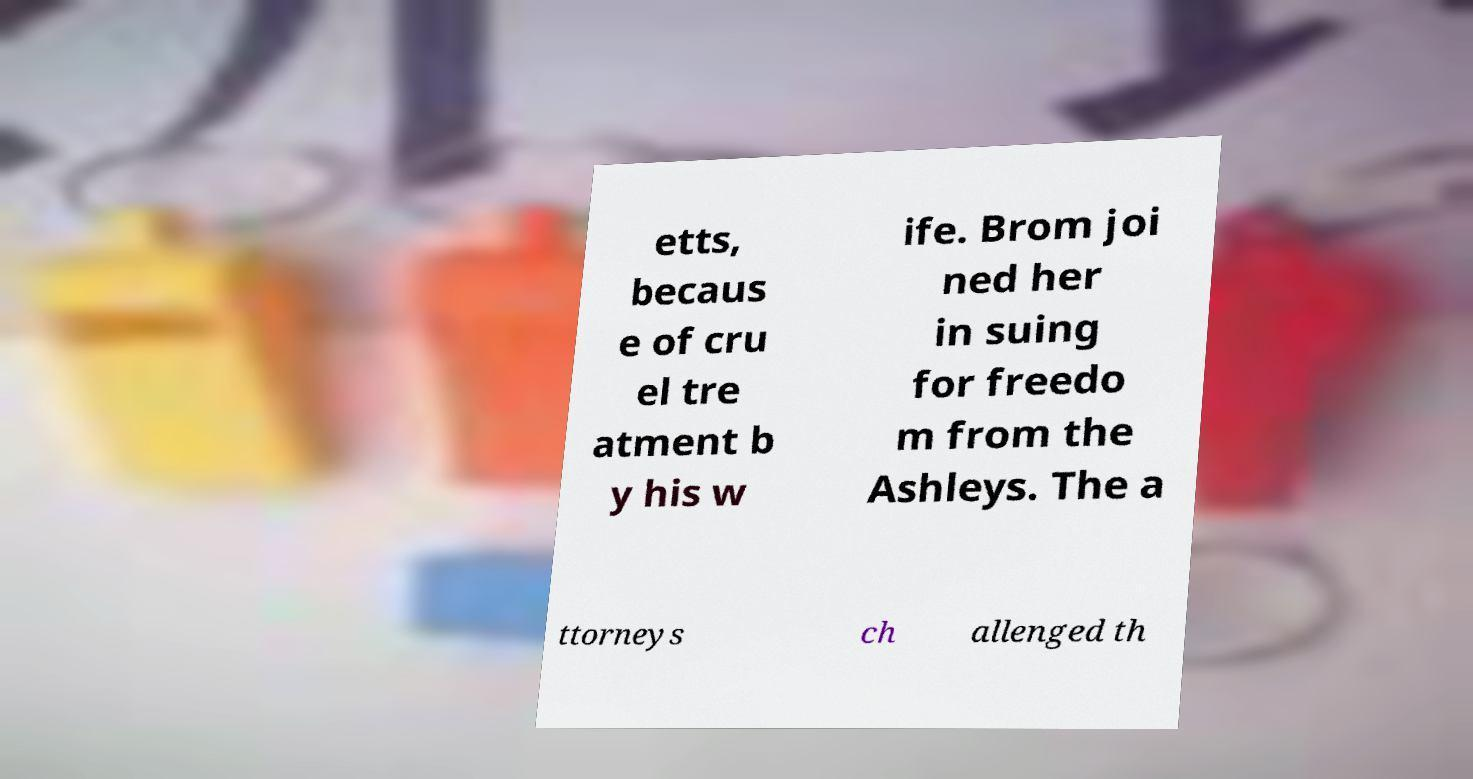I need the written content from this picture converted into text. Can you do that? etts, becaus e of cru el tre atment b y his w ife. Brom joi ned her in suing for freedo m from the Ashleys. The a ttorneys ch allenged th 